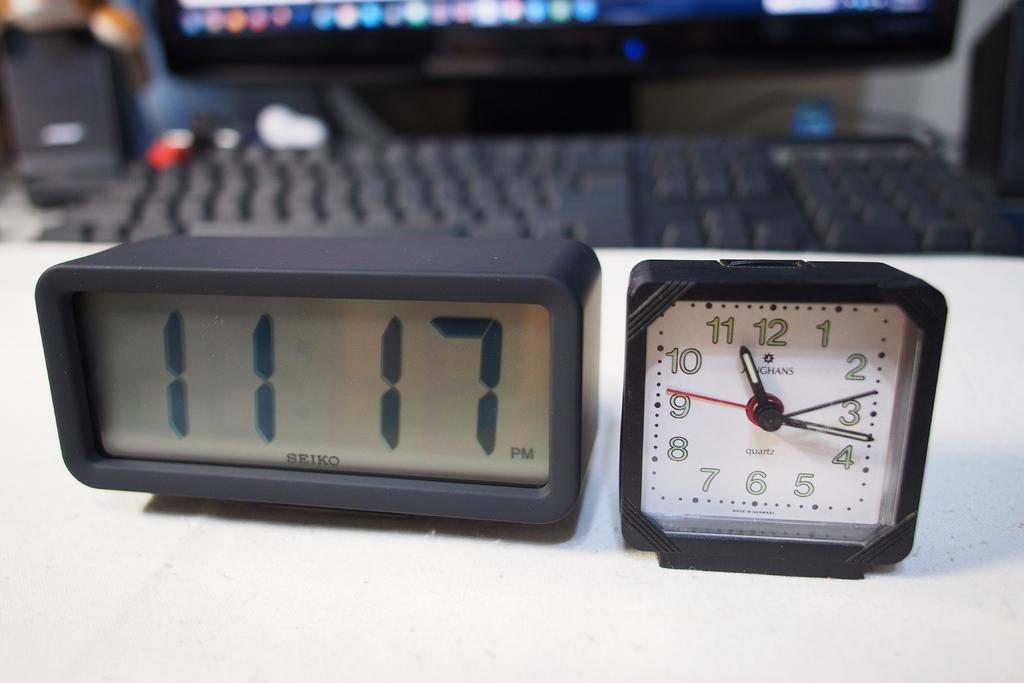What types of clocks are present in the image? There is a digital clock and an analog clock in the image. What other objects can be seen in the background of the image? There is a keyboard, a monitor, and a sound box in the background of the image. How many horses are visible in the image? There are no horses present in the image. What type of snail is crawling on the sound box in the image? There are no snails present in the image, and the sound box is not shown in enough detail to determine the presence of any creatures. 